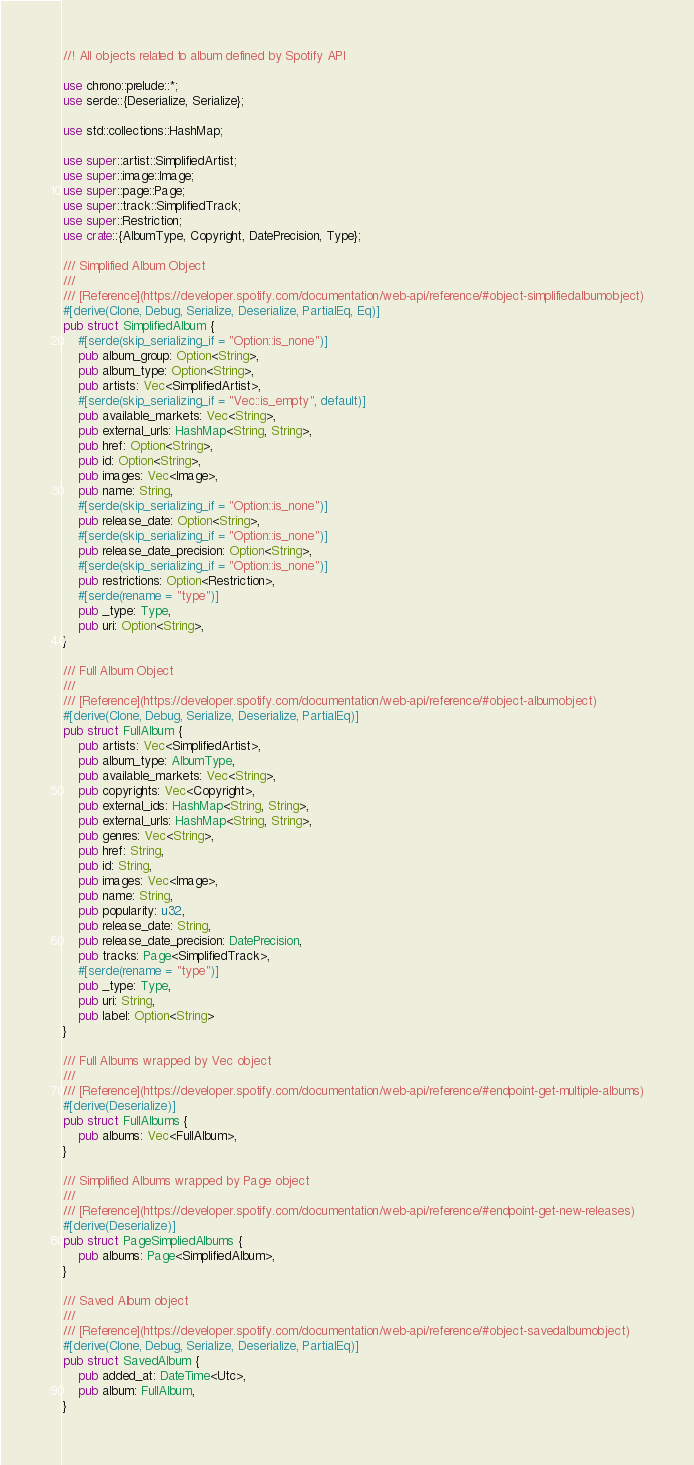<code> <loc_0><loc_0><loc_500><loc_500><_Rust_>//! All objects related to album defined by Spotify API

use chrono::prelude::*;
use serde::{Deserialize, Serialize};

use std::collections::HashMap;

use super::artist::SimplifiedArtist;
use super::image::Image;
use super::page::Page;
use super::track::SimplifiedTrack;
use super::Restriction;
use crate::{AlbumType, Copyright, DatePrecision, Type};

/// Simplified Album Object
///
/// [Reference](https://developer.spotify.com/documentation/web-api/reference/#object-simplifiedalbumobject)
#[derive(Clone, Debug, Serialize, Deserialize, PartialEq, Eq)]
pub struct SimplifiedAlbum {
    #[serde(skip_serializing_if = "Option::is_none")]
    pub album_group: Option<String>,
    pub album_type: Option<String>,
    pub artists: Vec<SimplifiedArtist>,
    #[serde(skip_serializing_if = "Vec::is_empty", default)]
    pub available_markets: Vec<String>,
    pub external_urls: HashMap<String, String>,
    pub href: Option<String>,
    pub id: Option<String>,
    pub images: Vec<Image>,
    pub name: String,
    #[serde(skip_serializing_if = "Option::is_none")]
    pub release_date: Option<String>,
    #[serde(skip_serializing_if = "Option::is_none")]
    pub release_date_precision: Option<String>,
    #[serde(skip_serializing_if = "Option::is_none")]
    pub restrictions: Option<Restriction>,
    #[serde(rename = "type")]
    pub _type: Type,
    pub uri: Option<String>,
}

/// Full Album Object
///
/// [Reference](https://developer.spotify.com/documentation/web-api/reference/#object-albumobject)
#[derive(Clone, Debug, Serialize, Deserialize, PartialEq)]
pub struct FullAlbum {
    pub artists: Vec<SimplifiedArtist>,
    pub album_type: AlbumType,
    pub available_markets: Vec<String>,
    pub copyrights: Vec<Copyright>,
    pub external_ids: HashMap<String, String>,
    pub external_urls: HashMap<String, String>,
    pub genres: Vec<String>,
    pub href: String,
    pub id: String,
    pub images: Vec<Image>,
    pub name: String,
    pub popularity: u32,
    pub release_date: String,
    pub release_date_precision: DatePrecision,
    pub tracks: Page<SimplifiedTrack>,
    #[serde(rename = "type")]
    pub _type: Type,
    pub uri: String,
    pub label: Option<String>
}

/// Full Albums wrapped by Vec object
///
/// [Reference](https://developer.spotify.com/documentation/web-api/reference/#endpoint-get-multiple-albums)
#[derive(Deserialize)]
pub struct FullAlbums {
    pub albums: Vec<FullAlbum>,
}

/// Simplified Albums wrapped by Page object
///
/// [Reference](https://developer.spotify.com/documentation/web-api/reference/#endpoint-get-new-releases)
#[derive(Deserialize)]
pub struct PageSimpliedAlbums {
    pub albums: Page<SimplifiedAlbum>,
}

/// Saved Album object
///
/// [Reference](https://developer.spotify.com/documentation/web-api/reference/#object-savedalbumobject)
#[derive(Clone, Debug, Serialize, Deserialize, PartialEq)]
pub struct SavedAlbum {
    pub added_at: DateTime<Utc>,
    pub album: FullAlbum,
}
</code> 